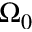<formula> <loc_0><loc_0><loc_500><loc_500>\Omega _ { 0 }</formula> 